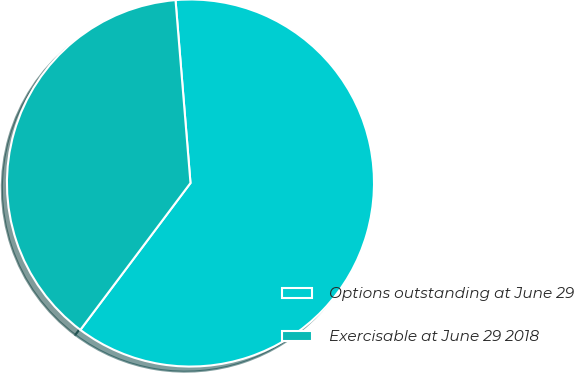<chart> <loc_0><loc_0><loc_500><loc_500><pie_chart><fcel>Options outstanding at June 29<fcel>Exercisable at June 29 2018<nl><fcel>61.54%<fcel>38.46%<nl></chart> 